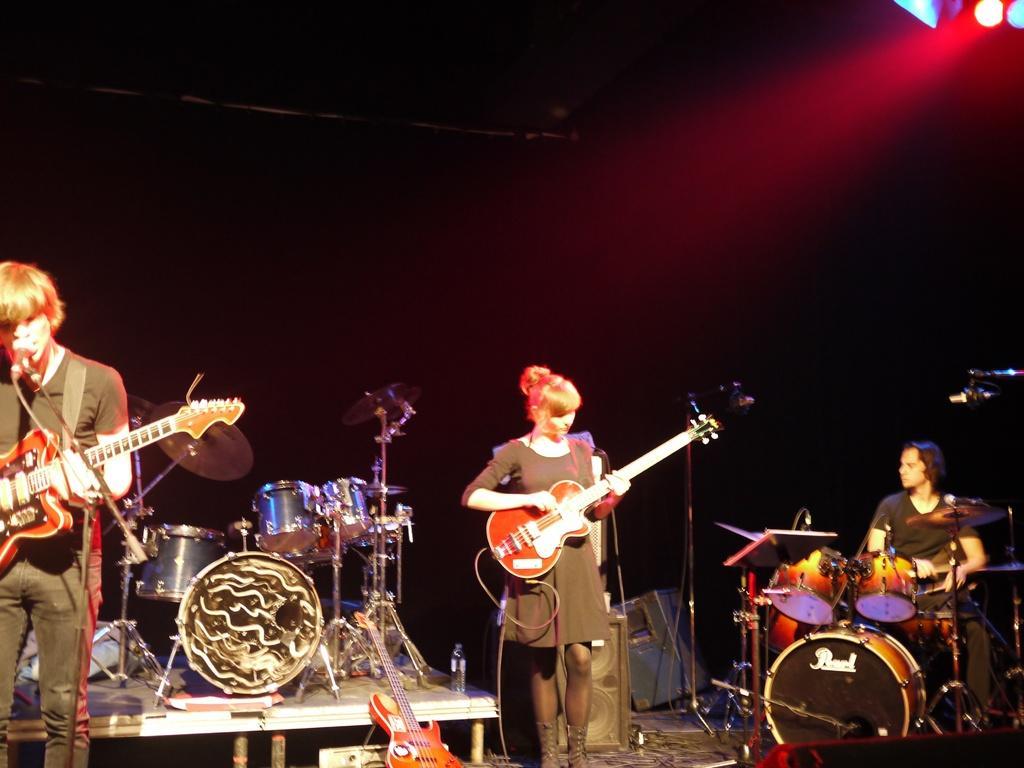Can you describe this image briefly? Here is the woman standing and playing guitar. This is the man standing and singing song. He playing guitar. These are the drums. I can see water bottle on the table. These are the speakers. Here is another man sitting and playing drums. This is the mic attached to the mike stand. The background is dark. At the top left corner I can see show light. This is another guitar. 